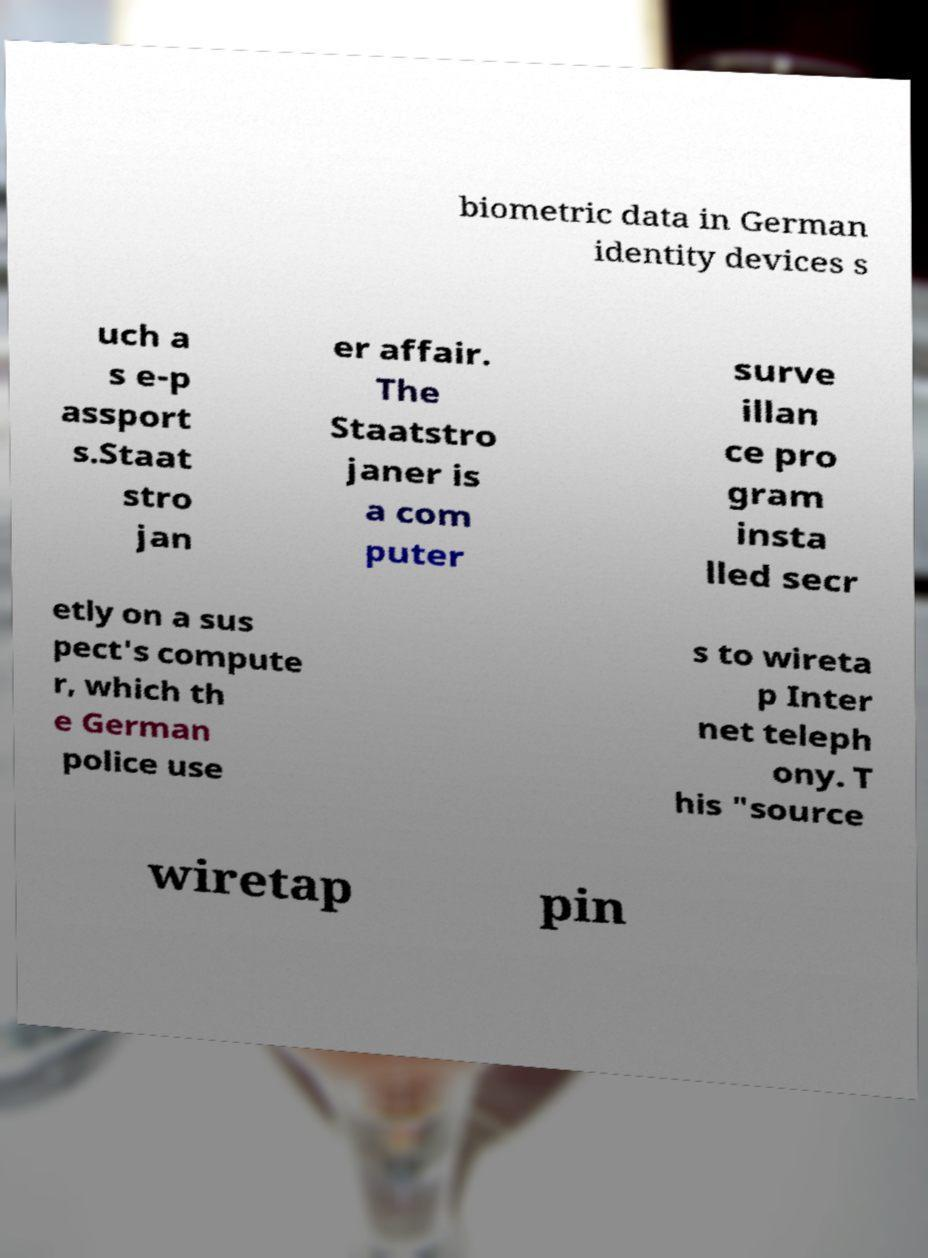Can you accurately transcribe the text from the provided image for me? biometric data in German identity devices s uch a s e-p assport s.Staat stro jan er affair. The Staatstro janer is a com puter surve illan ce pro gram insta lled secr etly on a sus pect's compute r, which th e German police use s to wireta p Inter net teleph ony. T his "source wiretap pin 